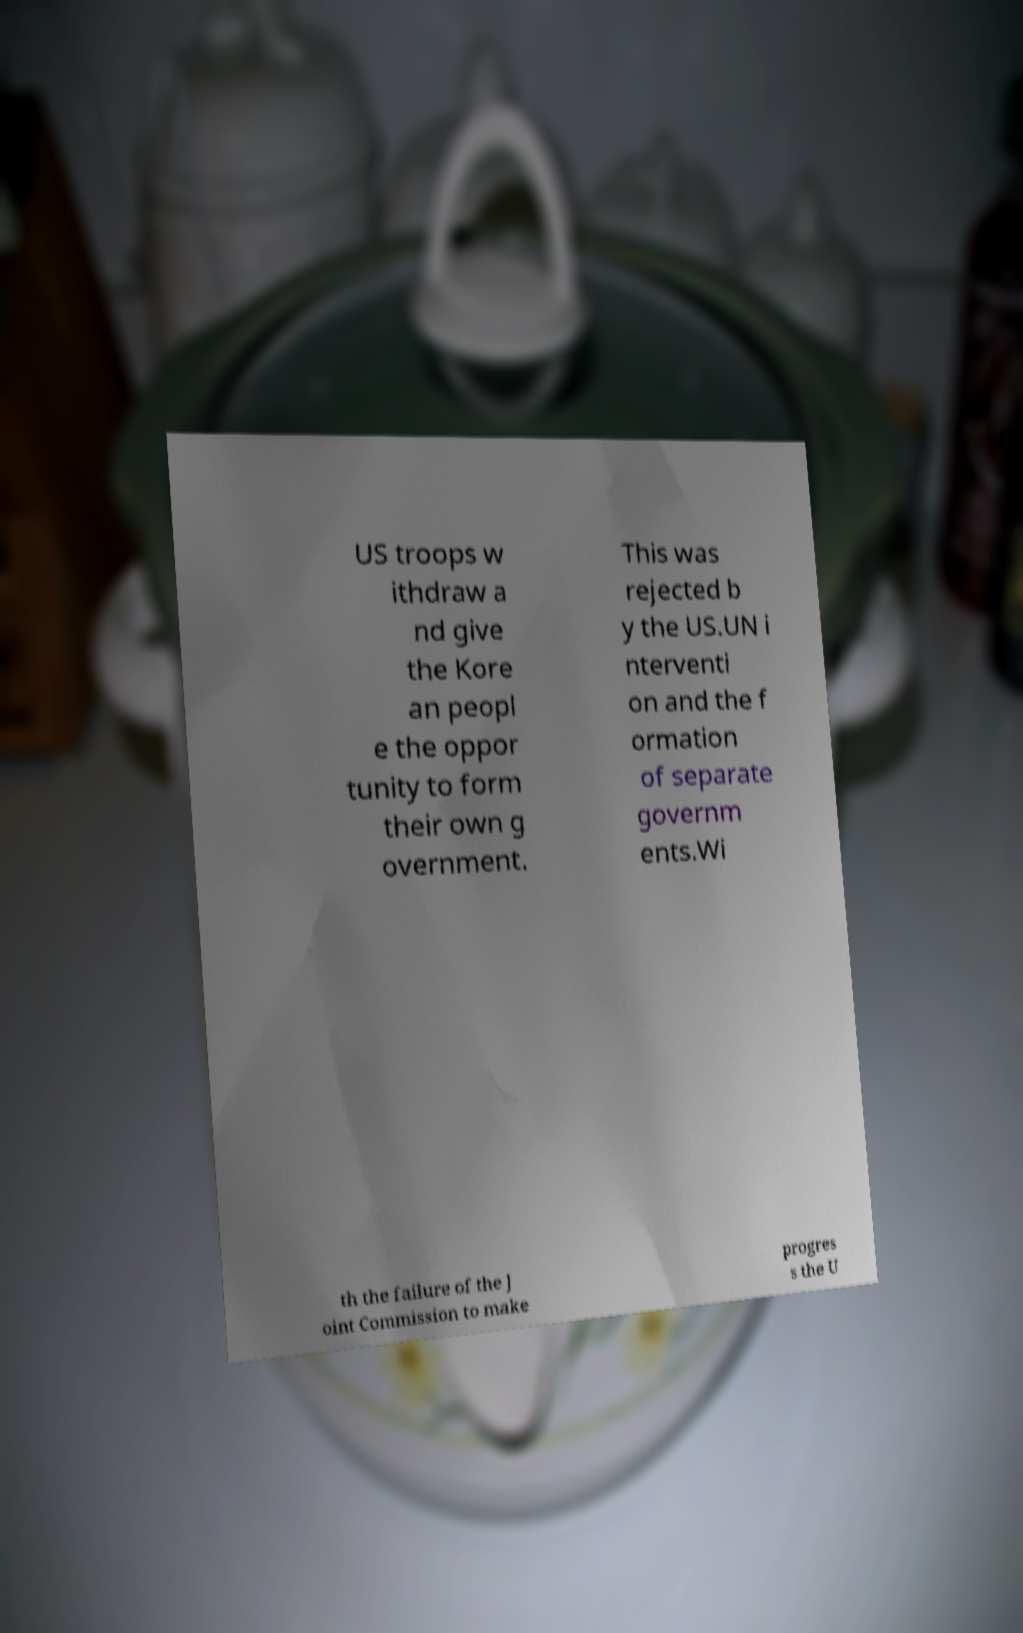Could you extract and type out the text from this image? US troops w ithdraw a nd give the Kore an peopl e the oppor tunity to form their own g overnment. This was rejected b y the US.UN i nterventi on and the f ormation of separate governm ents.Wi th the failure of the J oint Commission to make progres s the U 